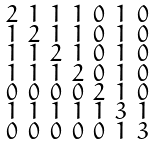Convert formula to latex. <formula><loc_0><loc_0><loc_500><loc_500>\begin{smallmatrix} 2 & 1 & 1 & 1 & 0 & 1 & 0 \\ 1 & 2 & 1 & 1 & 0 & 1 & 0 \\ 1 & 1 & 2 & 1 & 0 & 1 & 0 \\ 1 & 1 & 1 & 2 & 0 & 1 & 0 \\ 0 & 0 & 0 & 0 & 2 & 1 & 0 \\ 1 & 1 & 1 & 1 & 1 & 3 & 1 \\ 0 & 0 & 0 & 0 & 0 & 1 & 3 \end{smallmatrix}</formula> 